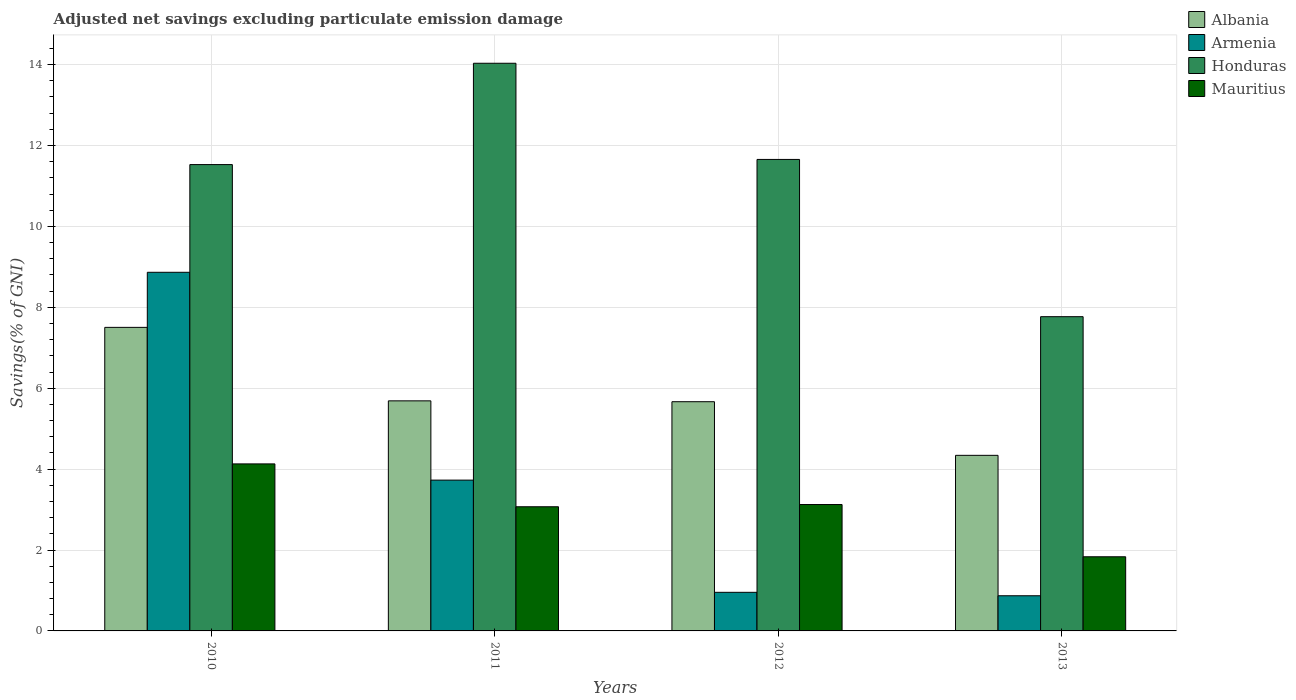How many different coloured bars are there?
Offer a terse response. 4. How many groups of bars are there?
Your answer should be very brief. 4. What is the label of the 3rd group of bars from the left?
Provide a succinct answer. 2012. What is the adjusted net savings in Armenia in 2013?
Your answer should be compact. 0.87. Across all years, what is the maximum adjusted net savings in Albania?
Make the answer very short. 7.5. Across all years, what is the minimum adjusted net savings in Armenia?
Make the answer very short. 0.87. In which year was the adjusted net savings in Mauritius maximum?
Your response must be concise. 2010. What is the total adjusted net savings in Armenia in the graph?
Your answer should be compact. 14.42. What is the difference between the adjusted net savings in Armenia in 2010 and that in 2011?
Your answer should be compact. 5.14. What is the difference between the adjusted net savings in Armenia in 2011 and the adjusted net savings in Honduras in 2012?
Provide a short and direct response. -7.93. What is the average adjusted net savings in Albania per year?
Give a very brief answer. 5.8. In the year 2011, what is the difference between the adjusted net savings in Mauritius and adjusted net savings in Albania?
Offer a terse response. -2.62. What is the ratio of the adjusted net savings in Honduras in 2010 to that in 2013?
Keep it short and to the point. 1.48. Is the difference between the adjusted net savings in Mauritius in 2010 and 2011 greater than the difference between the adjusted net savings in Albania in 2010 and 2011?
Provide a short and direct response. No. What is the difference between the highest and the second highest adjusted net savings in Armenia?
Your response must be concise. 5.14. What is the difference between the highest and the lowest adjusted net savings in Armenia?
Offer a very short reply. 8. In how many years, is the adjusted net savings in Armenia greater than the average adjusted net savings in Armenia taken over all years?
Your answer should be compact. 2. What does the 4th bar from the left in 2011 represents?
Provide a short and direct response. Mauritius. What does the 3rd bar from the right in 2012 represents?
Give a very brief answer. Armenia. Is it the case that in every year, the sum of the adjusted net savings in Armenia and adjusted net savings in Mauritius is greater than the adjusted net savings in Albania?
Provide a short and direct response. No. How many bars are there?
Make the answer very short. 16. Are all the bars in the graph horizontal?
Make the answer very short. No. What is the difference between two consecutive major ticks on the Y-axis?
Provide a short and direct response. 2. Are the values on the major ticks of Y-axis written in scientific E-notation?
Provide a short and direct response. No. Does the graph contain any zero values?
Your answer should be compact. No. Does the graph contain grids?
Ensure brevity in your answer.  Yes. How are the legend labels stacked?
Offer a very short reply. Vertical. What is the title of the graph?
Provide a short and direct response. Adjusted net savings excluding particulate emission damage. Does "Turkmenistan" appear as one of the legend labels in the graph?
Offer a terse response. No. What is the label or title of the X-axis?
Your answer should be compact. Years. What is the label or title of the Y-axis?
Provide a short and direct response. Savings(% of GNI). What is the Savings(% of GNI) of Albania in 2010?
Make the answer very short. 7.5. What is the Savings(% of GNI) of Armenia in 2010?
Keep it short and to the point. 8.87. What is the Savings(% of GNI) of Honduras in 2010?
Your answer should be compact. 11.53. What is the Savings(% of GNI) in Mauritius in 2010?
Your answer should be compact. 4.13. What is the Savings(% of GNI) of Albania in 2011?
Your response must be concise. 5.69. What is the Savings(% of GNI) in Armenia in 2011?
Keep it short and to the point. 3.73. What is the Savings(% of GNI) in Honduras in 2011?
Offer a terse response. 14.03. What is the Savings(% of GNI) of Mauritius in 2011?
Your answer should be compact. 3.07. What is the Savings(% of GNI) in Albania in 2012?
Ensure brevity in your answer.  5.67. What is the Savings(% of GNI) in Armenia in 2012?
Make the answer very short. 0.95. What is the Savings(% of GNI) in Honduras in 2012?
Make the answer very short. 11.66. What is the Savings(% of GNI) in Mauritius in 2012?
Offer a terse response. 3.12. What is the Savings(% of GNI) in Albania in 2013?
Offer a terse response. 4.34. What is the Savings(% of GNI) of Armenia in 2013?
Your answer should be very brief. 0.87. What is the Savings(% of GNI) in Honduras in 2013?
Provide a short and direct response. 7.77. What is the Savings(% of GNI) in Mauritius in 2013?
Make the answer very short. 1.83. Across all years, what is the maximum Savings(% of GNI) of Albania?
Keep it short and to the point. 7.5. Across all years, what is the maximum Savings(% of GNI) in Armenia?
Your response must be concise. 8.87. Across all years, what is the maximum Savings(% of GNI) in Honduras?
Ensure brevity in your answer.  14.03. Across all years, what is the maximum Savings(% of GNI) of Mauritius?
Give a very brief answer. 4.13. Across all years, what is the minimum Savings(% of GNI) of Albania?
Your answer should be very brief. 4.34. Across all years, what is the minimum Savings(% of GNI) in Armenia?
Keep it short and to the point. 0.87. Across all years, what is the minimum Savings(% of GNI) in Honduras?
Your answer should be very brief. 7.77. Across all years, what is the minimum Savings(% of GNI) of Mauritius?
Your response must be concise. 1.83. What is the total Savings(% of GNI) of Albania in the graph?
Your response must be concise. 23.2. What is the total Savings(% of GNI) in Armenia in the graph?
Your answer should be compact. 14.42. What is the total Savings(% of GNI) of Honduras in the graph?
Offer a terse response. 44.99. What is the total Savings(% of GNI) in Mauritius in the graph?
Ensure brevity in your answer.  12.16. What is the difference between the Savings(% of GNI) of Albania in 2010 and that in 2011?
Offer a terse response. 1.82. What is the difference between the Savings(% of GNI) of Armenia in 2010 and that in 2011?
Provide a succinct answer. 5.14. What is the difference between the Savings(% of GNI) in Honduras in 2010 and that in 2011?
Keep it short and to the point. -2.5. What is the difference between the Savings(% of GNI) of Mauritius in 2010 and that in 2011?
Offer a terse response. 1.06. What is the difference between the Savings(% of GNI) of Albania in 2010 and that in 2012?
Keep it short and to the point. 1.84. What is the difference between the Savings(% of GNI) of Armenia in 2010 and that in 2012?
Provide a succinct answer. 7.91. What is the difference between the Savings(% of GNI) in Honduras in 2010 and that in 2012?
Provide a short and direct response. -0.13. What is the difference between the Savings(% of GNI) in Mauritius in 2010 and that in 2012?
Make the answer very short. 1. What is the difference between the Savings(% of GNI) of Albania in 2010 and that in 2013?
Ensure brevity in your answer.  3.16. What is the difference between the Savings(% of GNI) in Armenia in 2010 and that in 2013?
Provide a succinct answer. 8. What is the difference between the Savings(% of GNI) in Honduras in 2010 and that in 2013?
Offer a terse response. 3.76. What is the difference between the Savings(% of GNI) of Mauritius in 2010 and that in 2013?
Ensure brevity in your answer.  2.3. What is the difference between the Savings(% of GNI) of Albania in 2011 and that in 2012?
Your answer should be compact. 0.02. What is the difference between the Savings(% of GNI) in Armenia in 2011 and that in 2012?
Provide a succinct answer. 2.77. What is the difference between the Savings(% of GNI) in Honduras in 2011 and that in 2012?
Your response must be concise. 2.38. What is the difference between the Savings(% of GNI) of Mauritius in 2011 and that in 2012?
Offer a very short reply. -0.06. What is the difference between the Savings(% of GNI) of Albania in 2011 and that in 2013?
Make the answer very short. 1.35. What is the difference between the Savings(% of GNI) in Armenia in 2011 and that in 2013?
Offer a very short reply. 2.86. What is the difference between the Savings(% of GNI) in Honduras in 2011 and that in 2013?
Keep it short and to the point. 6.27. What is the difference between the Savings(% of GNI) in Mauritius in 2011 and that in 2013?
Your response must be concise. 1.24. What is the difference between the Savings(% of GNI) of Albania in 2012 and that in 2013?
Ensure brevity in your answer.  1.33. What is the difference between the Savings(% of GNI) of Armenia in 2012 and that in 2013?
Keep it short and to the point. 0.08. What is the difference between the Savings(% of GNI) in Honduras in 2012 and that in 2013?
Ensure brevity in your answer.  3.89. What is the difference between the Savings(% of GNI) of Mauritius in 2012 and that in 2013?
Provide a succinct answer. 1.29. What is the difference between the Savings(% of GNI) in Albania in 2010 and the Savings(% of GNI) in Armenia in 2011?
Provide a succinct answer. 3.78. What is the difference between the Savings(% of GNI) in Albania in 2010 and the Savings(% of GNI) in Honduras in 2011?
Make the answer very short. -6.53. What is the difference between the Savings(% of GNI) in Albania in 2010 and the Savings(% of GNI) in Mauritius in 2011?
Your answer should be very brief. 4.43. What is the difference between the Savings(% of GNI) of Armenia in 2010 and the Savings(% of GNI) of Honduras in 2011?
Your response must be concise. -5.17. What is the difference between the Savings(% of GNI) in Armenia in 2010 and the Savings(% of GNI) in Mauritius in 2011?
Keep it short and to the point. 5.8. What is the difference between the Savings(% of GNI) in Honduras in 2010 and the Savings(% of GNI) in Mauritius in 2011?
Offer a terse response. 8.46. What is the difference between the Savings(% of GNI) in Albania in 2010 and the Savings(% of GNI) in Armenia in 2012?
Your answer should be very brief. 6.55. What is the difference between the Savings(% of GNI) of Albania in 2010 and the Savings(% of GNI) of Honduras in 2012?
Ensure brevity in your answer.  -4.15. What is the difference between the Savings(% of GNI) of Albania in 2010 and the Savings(% of GNI) of Mauritius in 2012?
Provide a succinct answer. 4.38. What is the difference between the Savings(% of GNI) of Armenia in 2010 and the Savings(% of GNI) of Honduras in 2012?
Provide a succinct answer. -2.79. What is the difference between the Savings(% of GNI) of Armenia in 2010 and the Savings(% of GNI) of Mauritius in 2012?
Your answer should be very brief. 5.74. What is the difference between the Savings(% of GNI) of Honduras in 2010 and the Savings(% of GNI) of Mauritius in 2012?
Your response must be concise. 8.4. What is the difference between the Savings(% of GNI) in Albania in 2010 and the Savings(% of GNI) in Armenia in 2013?
Provide a short and direct response. 6.63. What is the difference between the Savings(% of GNI) in Albania in 2010 and the Savings(% of GNI) in Honduras in 2013?
Your answer should be very brief. -0.26. What is the difference between the Savings(% of GNI) of Albania in 2010 and the Savings(% of GNI) of Mauritius in 2013?
Your response must be concise. 5.67. What is the difference between the Savings(% of GNI) of Armenia in 2010 and the Savings(% of GNI) of Honduras in 2013?
Your answer should be compact. 1.1. What is the difference between the Savings(% of GNI) of Armenia in 2010 and the Savings(% of GNI) of Mauritius in 2013?
Your response must be concise. 7.03. What is the difference between the Savings(% of GNI) in Honduras in 2010 and the Savings(% of GNI) in Mauritius in 2013?
Your response must be concise. 9.7. What is the difference between the Savings(% of GNI) of Albania in 2011 and the Savings(% of GNI) of Armenia in 2012?
Make the answer very short. 4.73. What is the difference between the Savings(% of GNI) in Albania in 2011 and the Savings(% of GNI) in Honduras in 2012?
Give a very brief answer. -5.97. What is the difference between the Savings(% of GNI) in Albania in 2011 and the Savings(% of GNI) in Mauritius in 2012?
Ensure brevity in your answer.  2.56. What is the difference between the Savings(% of GNI) of Armenia in 2011 and the Savings(% of GNI) of Honduras in 2012?
Provide a short and direct response. -7.93. What is the difference between the Savings(% of GNI) of Armenia in 2011 and the Savings(% of GNI) of Mauritius in 2012?
Give a very brief answer. 0.6. What is the difference between the Savings(% of GNI) in Honduras in 2011 and the Savings(% of GNI) in Mauritius in 2012?
Give a very brief answer. 10.91. What is the difference between the Savings(% of GNI) in Albania in 2011 and the Savings(% of GNI) in Armenia in 2013?
Your answer should be very brief. 4.82. What is the difference between the Savings(% of GNI) of Albania in 2011 and the Savings(% of GNI) of Honduras in 2013?
Ensure brevity in your answer.  -2.08. What is the difference between the Savings(% of GNI) in Albania in 2011 and the Savings(% of GNI) in Mauritius in 2013?
Keep it short and to the point. 3.85. What is the difference between the Savings(% of GNI) in Armenia in 2011 and the Savings(% of GNI) in Honduras in 2013?
Give a very brief answer. -4.04. What is the difference between the Savings(% of GNI) in Armenia in 2011 and the Savings(% of GNI) in Mauritius in 2013?
Provide a succinct answer. 1.9. What is the difference between the Savings(% of GNI) in Honduras in 2011 and the Savings(% of GNI) in Mauritius in 2013?
Make the answer very short. 12.2. What is the difference between the Savings(% of GNI) of Albania in 2012 and the Savings(% of GNI) of Armenia in 2013?
Provide a short and direct response. 4.8. What is the difference between the Savings(% of GNI) in Albania in 2012 and the Savings(% of GNI) in Honduras in 2013?
Your answer should be very brief. -2.1. What is the difference between the Savings(% of GNI) in Albania in 2012 and the Savings(% of GNI) in Mauritius in 2013?
Offer a very short reply. 3.83. What is the difference between the Savings(% of GNI) in Armenia in 2012 and the Savings(% of GNI) in Honduras in 2013?
Ensure brevity in your answer.  -6.81. What is the difference between the Savings(% of GNI) of Armenia in 2012 and the Savings(% of GNI) of Mauritius in 2013?
Offer a terse response. -0.88. What is the difference between the Savings(% of GNI) in Honduras in 2012 and the Savings(% of GNI) in Mauritius in 2013?
Provide a short and direct response. 9.82. What is the average Savings(% of GNI) of Albania per year?
Your response must be concise. 5.8. What is the average Savings(% of GNI) of Armenia per year?
Make the answer very short. 3.6. What is the average Savings(% of GNI) of Honduras per year?
Keep it short and to the point. 11.25. What is the average Savings(% of GNI) of Mauritius per year?
Ensure brevity in your answer.  3.04. In the year 2010, what is the difference between the Savings(% of GNI) of Albania and Savings(% of GNI) of Armenia?
Provide a short and direct response. -1.36. In the year 2010, what is the difference between the Savings(% of GNI) in Albania and Savings(% of GNI) in Honduras?
Your response must be concise. -4.02. In the year 2010, what is the difference between the Savings(% of GNI) of Albania and Savings(% of GNI) of Mauritius?
Provide a short and direct response. 3.38. In the year 2010, what is the difference between the Savings(% of GNI) in Armenia and Savings(% of GNI) in Honduras?
Your answer should be very brief. -2.66. In the year 2010, what is the difference between the Savings(% of GNI) in Armenia and Savings(% of GNI) in Mauritius?
Provide a succinct answer. 4.74. In the year 2010, what is the difference between the Savings(% of GNI) in Honduras and Savings(% of GNI) in Mauritius?
Keep it short and to the point. 7.4. In the year 2011, what is the difference between the Savings(% of GNI) of Albania and Savings(% of GNI) of Armenia?
Give a very brief answer. 1.96. In the year 2011, what is the difference between the Savings(% of GNI) in Albania and Savings(% of GNI) in Honduras?
Your answer should be very brief. -8.35. In the year 2011, what is the difference between the Savings(% of GNI) in Albania and Savings(% of GNI) in Mauritius?
Keep it short and to the point. 2.62. In the year 2011, what is the difference between the Savings(% of GNI) in Armenia and Savings(% of GNI) in Honduras?
Provide a succinct answer. -10.31. In the year 2011, what is the difference between the Savings(% of GNI) of Armenia and Savings(% of GNI) of Mauritius?
Your answer should be very brief. 0.66. In the year 2011, what is the difference between the Savings(% of GNI) of Honduras and Savings(% of GNI) of Mauritius?
Your answer should be compact. 10.96. In the year 2012, what is the difference between the Savings(% of GNI) of Albania and Savings(% of GNI) of Armenia?
Provide a succinct answer. 4.71. In the year 2012, what is the difference between the Savings(% of GNI) of Albania and Savings(% of GNI) of Honduras?
Ensure brevity in your answer.  -5.99. In the year 2012, what is the difference between the Savings(% of GNI) in Albania and Savings(% of GNI) in Mauritius?
Offer a very short reply. 2.54. In the year 2012, what is the difference between the Savings(% of GNI) in Armenia and Savings(% of GNI) in Honduras?
Ensure brevity in your answer.  -10.7. In the year 2012, what is the difference between the Savings(% of GNI) in Armenia and Savings(% of GNI) in Mauritius?
Provide a succinct answer. -2.17. In the year 2012, what is the difference between the Savings(% of GNI) of Honduras and Savings(% of GNI) of Mauritius?
Ensure brevity in your answer.  8.53. In the year 2013, what is the difference between the Savings(% of GNI) in Albania and Savings(% of GNI) in Armenia?
Your response must be concise. 3.47. In the year 2013, what is the difference between the Savings(% of GNI) in Albania and Savings(% of GNI) in Honduras?
Your answer should be very brief. -3.43. In the year 2013, what is the difference between the Savings(% of GNI) in Albania and Savings(% of GNI) in Mauritius?
Offer a terse response. 2.51. In the year 2013, what is the difference between the Savings(% of GNI) in Armenia and Savings(% of GNI) in Honduras?
Provide a succinct answer. -6.9. In the year 2013, what is the difference between the Savings(% of GNI) in Armenia and Savings(% of GNI) in Mauritius?
Offer a terse response. -0.96. In the year 2013, what is the difference between the Savings(% of GNI) in Honduras and Savings(% of GNI) in Mauritius?
Your answer should be compact. 5.94. What is the ratio of the Savings(% of GNI) of Albania in 2010 to that in 2011?
Give a very brief answer. 1.32. What is the ratio of the Savings(% of GNI) in Armenia in 2010 to that in 2011?
Give a very brief answer. 2.38. What is the ratio of the Savings(% of GNI) in Honduras in 2010 to that in 2011?
Make the answer very short. 0.82. What is the ratio of the Savings(% of GNI) in Mauritius in 2010 to that in 2011?
Provide a short and direct response. 1.35. What is the ratio of the Savings(% of GNI) of Albania in 2010 to that in 2012?
Ensure brevity in your answer.  1.32. What is the ratio of the Savings(% of GNI) in Armenia in 2010 to that in 2012?
Make the answer very short. 9.29. What is the ratio of the Savings(% of GNI) of Mauritius in 2010 to that in 2012?
Offer a very short reply. 1.32. What is the ratio of the Savings(% of GNI) of Albania in 2010 to that in 2013?
Provide a succinct answer. 1.73. What is the ratio of the Savings(% of GNI) in Armenia in 2010 to that in 2013?
Provide a succinct answer. 10.2. What is the ratio of the Savings(% of GNI) of Honduras in 2010 to that in 2013?
Your answer should be compact. 1.48. What is the ratio of the Savings(% of GNI) of Mauritius in 2010 to that in 2013?
Your answer should be compact. 2.25. What is the ratio of the Savings(% of GNI) of Armenia in 2011 to that in 2012?
Keep it short and to the point. 3.91. What is the ratio of the Savings(% of GNI) of Honduras in 2011 to that in 2012?
Provide a short and direct response. 1.2. What is the ratio of the Savings(% of GNI) of Mauritius in 2011 to that in 2012?
Your response must be concise. 0.98. What is the ratio of the Savings(% of GNI) in Albania in 2011 to that in 2013?
Make the answer very short. 1.31. What is the ratio of the Savings(% of GNI) of Armenia in 2011 to that in 2013?
Give a very brief answer. 4.29. What is the ratio of the Savings(% of GNI) of Honduras in 2011 to that in 2013?
Offer a very short reply. 1.81. What is the ratio of the Savings(% of GNI) of Mauritius in 2011 to that in 2013?
Offer a very short reply. 1.67. What is the ratio of the Savings(% of GNI) of Albania in 2012 to that in 2013?
Offer a terse response. 1.31. What is the ratio of the Savings(% of GNI) of Armenia in 2012 to that in 2013?
Provide a short and direct response. 1.1. What is the ratio of the Savings(% of GNI) in Honduras in 2012 to that in 2013?
Provide a short and direct response. 1.5. What is the ratio of the Savings(% of GNI) in Mauritius in 2012 to that in 2013?
Your response must be concise. 1.7. What is the difference between the highest and the second highest Savings(% of GNI) in Albania?
Offer a terse response. 1.82. What is the difference between the highest and the second highest Savings(% of GNI) in Armenia?
Make the answer very short. 5.14. What is the difference between the highest and the second highest Savings(% of GNI) in Honduras?
Your answer should be very brief. 2.38. What is the difference between the highest and the second highest Savings(% of GNI) of Mauritius?
Make the answer very short. 1. What is the difference between the highest and the lowest Savings(% of GNI) in Albania?
Provide a succinct answer. 3.16. What is the difference between the highest and the lowest Savings(% of GNI) in Armenia?
Give a very brief answer. 8. What is the difference between the highest and the lowest Savings(% of GNI) in Honduras?
Ensure brevity in your answer.  6.27. What is the difference between the highest and the lowest Savings(% of GNI) in Mauritius?
Make the answer very short. 2.3. 